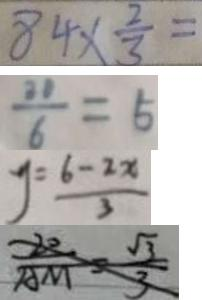Convert formula to latex. <formula><loc_0><loc_0><loc_500><loc_500>8 4 \times \frac { 2 } { 3 } = 
 \frac { 2 1 } { 6 } = 5 
 y = \frac { 6 - 2 x } { 3 } 
 \frac { 2 0 } { A M } = \frac { \sqrt { 3 } } { 3 }</formula> 